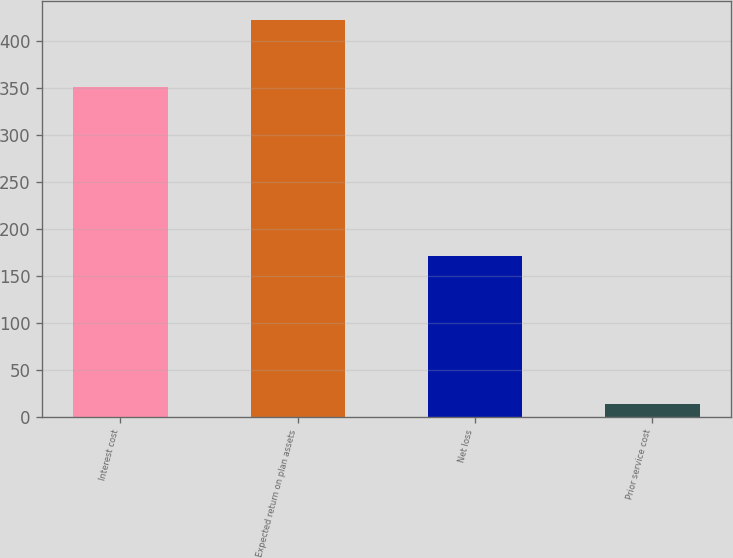Convert chart. <chart><loc_0><loc_0><loc_500><loc_500><bar_chart><fcel>Interest cost<fcel>Expected return on plan assets<fcel>Net loss<fcel>Prior service cost<nl><fcel>351<fcel>422<fcel>171<fcel>14<nl></chart> 